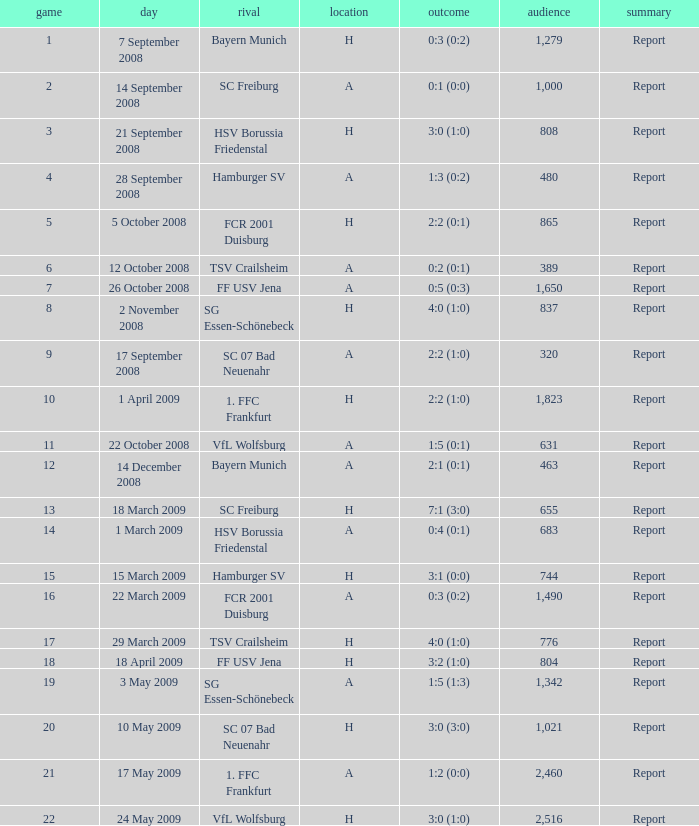Which match had more than 1,490 people in attendance to watch FCR 2001 Duisburg have a result of 0:3 (0:2)? None. 